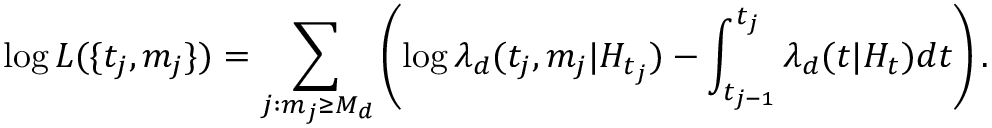Convert formula to latex. <formula><loc_0><loc_0><loc_500><loc_500>\log L ( \{ t _ { j } , m _ { j } \} ) = \sum _ { j \colon m _ { j } \geq M _ { d } } \left ( \log \lambda _ { d } ( t _ { j } , m _ { j } | H _ { t _ { j } } ) - \int _ { t _ { j - 1 } } ^ { t _ { j } } \lambda _ { d } ( t | H _ { t } ) d t \right ) .</formula> 